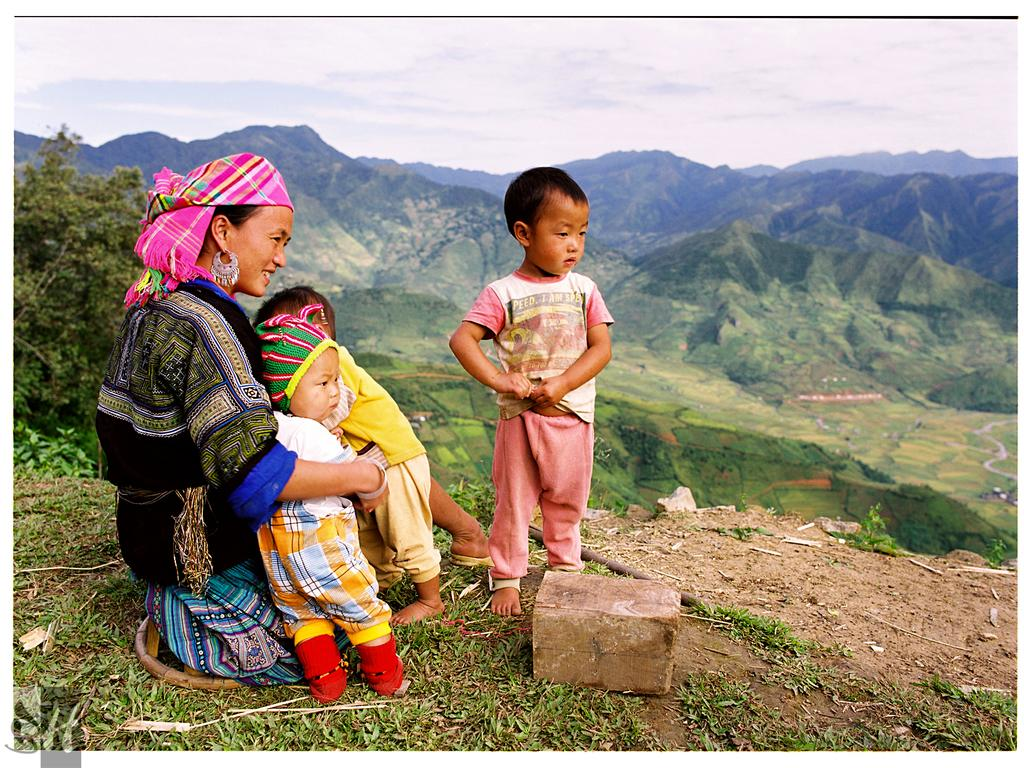Who or what is present in the image? There are people in the image. What type of natural environment is depicted in the image? There is grass, mountains, and trees in the image. What can be seen in the background of the image? The sky is visible in the background of the image, and clouds are present in the sky. Where is the glove located in the image? There is no glove present in the image. What type of animals can be seen at the zoo in the image? There is no zoo present in the image. 